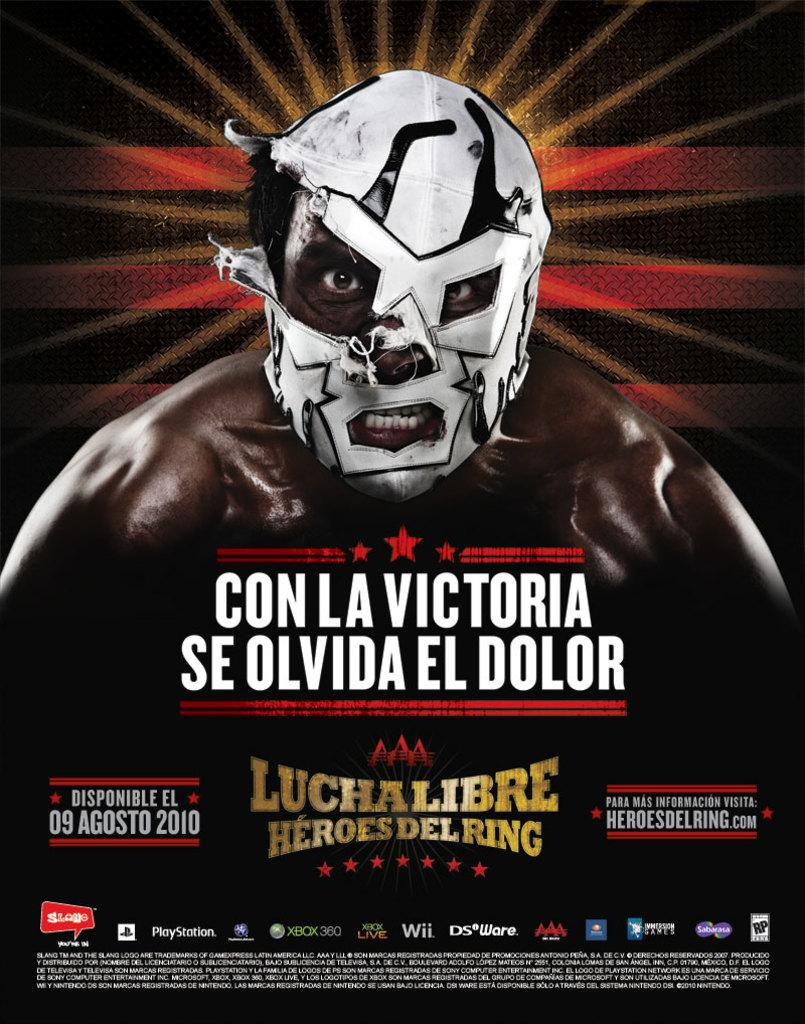What is the main subject of the image? The main subject of the image is an advertisement. Can you describe the person in the image? There is a person wearing a mask in the center of the image. What else can be found at the bottom of the image? There is text at the bottom of the image. What type of liquid can be seen flowing from the star in the image? There is no star or liquid present in the image. 